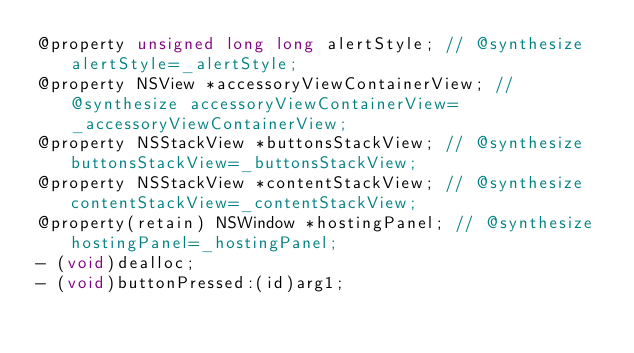<code> <loc_0><loc_0><loc_500><loc_500><_C_>@property unsigned long long alertStyle; // @synthesize alertStyle=_alertStyle;
@property NSView *accessoryViewContainerView; // @synthesize accessoryViewContainerView=_accessoryViewContainerView;
@property NSStackView *buttonsStackView; // @synthesize buttonsStackView=_buttonsStackView;
@property NSStackView *contentStackView; // @synthesize contentStackView=_contentStackView;
@property(retain) NSWindow *hostingPanel; // @synthesize hostingPanel=_hostingPanel;
- (void)dealloc;
- (void)buttonPressed:(id)arg1;</code> 